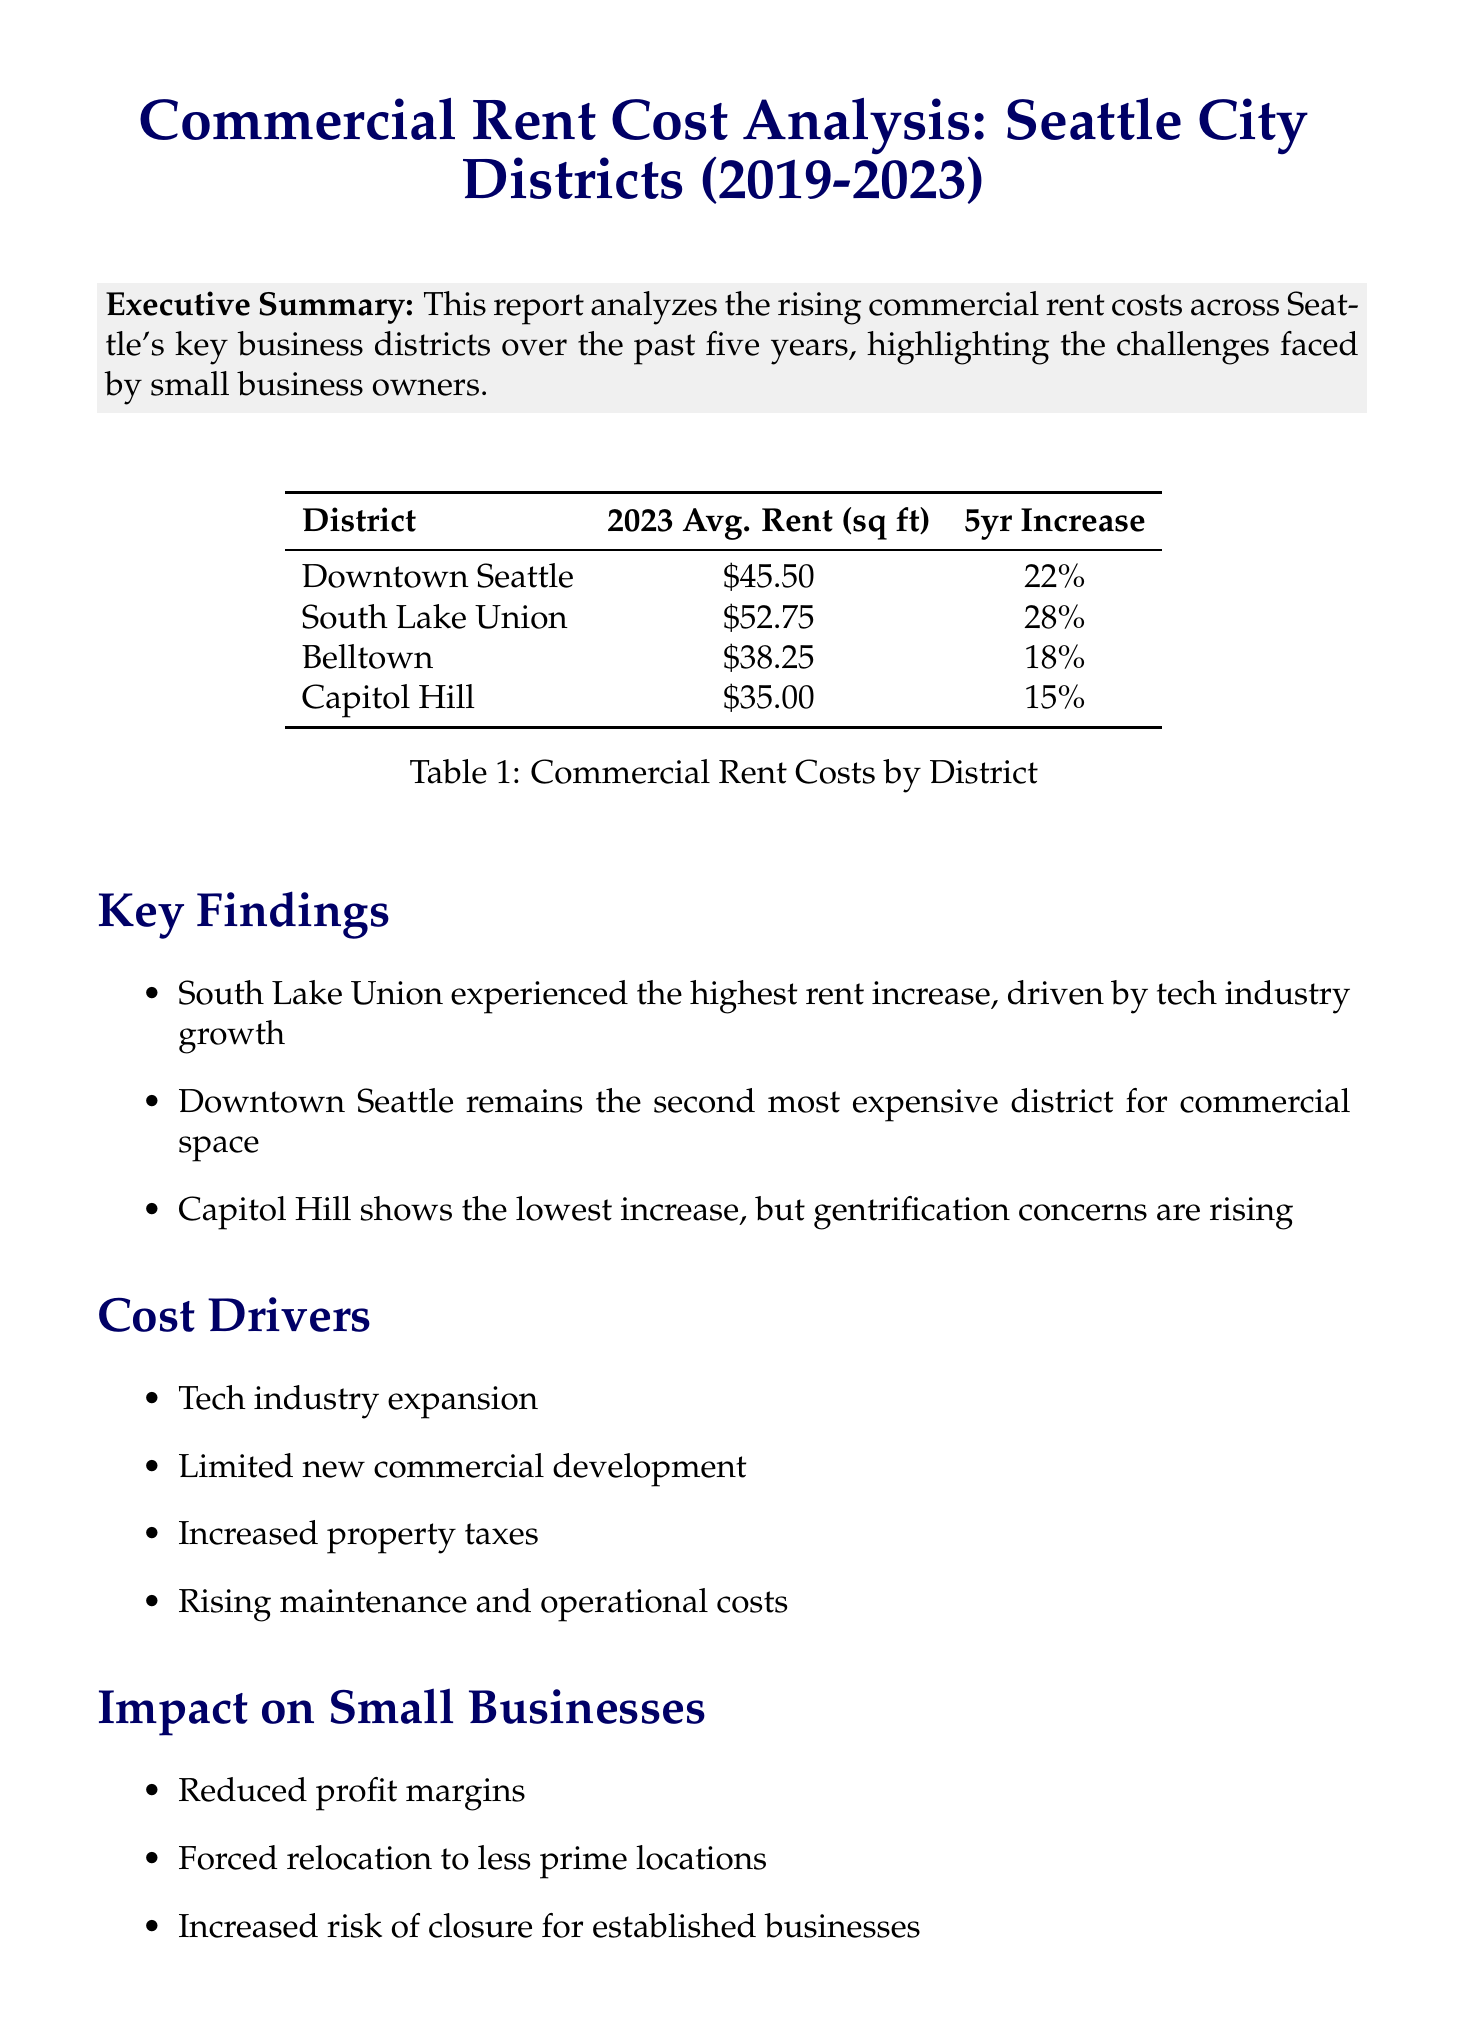What is the average rent per square foot in South Lake Union? The average rent per square foot in South Lake Union is explicitly stated in the data points section of the document.
Answer: $52.75 What was the percentage increase in rent for Downtown Seattle over the last five years? This information is presented within the data points, reflecting changes over a specified period.
Answer: 22% Which district had the highest rent increase percentage? By comparing the 5-year increase percentages in the key findings, we can identify the district with the highest increase.
Answer: South Lake Union What impact does rising rent have on small businesses? The report outlines several impacts on small businesses related to increasing commercial rents, listed under a dedicated section.
Answer: Reduced profit margins What is one recommendation made for small business owners facing rising rent costs? The report provides several suggestions for small businesses to navigate increasing rents, highlighting practical strategies.
Answer: Explore shared workspace options 